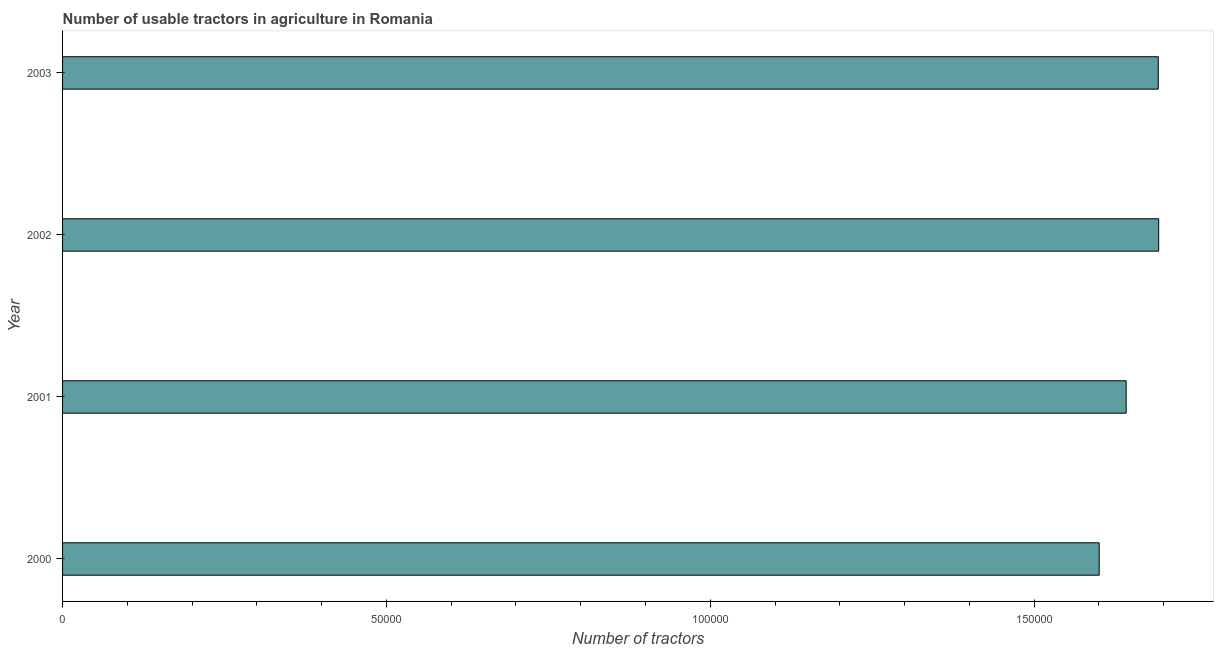Does the graph contain any zero values?
Your answer should be compact. No. Does the graph contain grids?
Offer a terse response. No. What is the title of the graph?
Offer a very short reply. Number of usable tractors in agriculture in Romania. What is the label or title of the X-axis?
Ensure brevity in your answer.  Number of tractors. What is the label or title of the Y-axis?
Offer a terse response. Year. What is the number of tractors in 2002?
Offer a terse response. 1.69e+05. Across all years, what is the maximum number of tractors?
Keep it short and to the point. 1.69e+05. Across all years, what is the minimum number of tractors?
Provide a succinct answer. 1.60e+05. In which year was the number of tractors maximum?
Keep it short and to the point. 2002. What is the sum of the number of tractors?
Offer a terse response. 6.63e+05. What is the difference between the number of tractors in 2001 and 2003?
Offer a terse response. -4956. What is the average number of tractors per year?
Give a very brief answer. 1.66e+05. What is the median number of tractors?
Your answer should be very brief. 1.67e+05. In how many years, is the number of tractors greater than 80000 ?
Provide a succinct answer. 4. What is the ratio of the number of tractors in 2000 to that in 2002?
Make the answer very short. 0.95. Is the difference between the number of tractors in 2001 and 2003 greater than the difference between any two years?
Keep it short and to the point. No. Is the sum of the number of tractors in 2000 and 2001 greater than the maximum number of tractors across all years?
Provide a short and direct response. Yes. What is the difference between the highest and the lowest number of tractors?
Provide a short and direct response. 9187. In how many years, is the number of tractors greater than the average number of tractors taken over all years?
Your response must be concise. 2. Are all the bars in the graph horizontal?
Keep it short and to the point. Yes. What is the difference between two consecutive major ticks on the X-axis?
Your answer should be compact. 5.00e+04. What is the Number of tractors of 2000?
Give a very brief answer. 1.60e+05. What is the Number of tractors in 2001?
Offer a terse response. 1.64e+05. What is the Number of tractors of 2002?
Your response must be concise. 1.69e+05. What is the Number of tractors of 2003?
Make the answer very short. 1.69e+05. What is the difference between the Number of tractors in 2000 and 2001?
Offer a terse response. -4168. What is the difference between the Number of tractors in 2000 and 2002?
Keep it short and to the point. -9187. What is the difference between the Number of tractors in 2000 and 2003?
Give a very brief answer. -9124. What is the difference between the Number of tractors in 2001 and 2002?
Ensure brevity in your answer.  -5019. What is the difference between the Number of tractors in 2001 and 2003?
Your answer should be compact. -4956. What is the difference between the Number of tractors in 2002 and 2003?
Give a very brief answer. 63. What is the ratio of the Number of tractors in 2000 to that in 2002?
Ensure brevity in your answer.  0.95. What is the ratio of the Number of tractors in 2000 to that in 2003?
Keep it short and to the point. 0.95. 